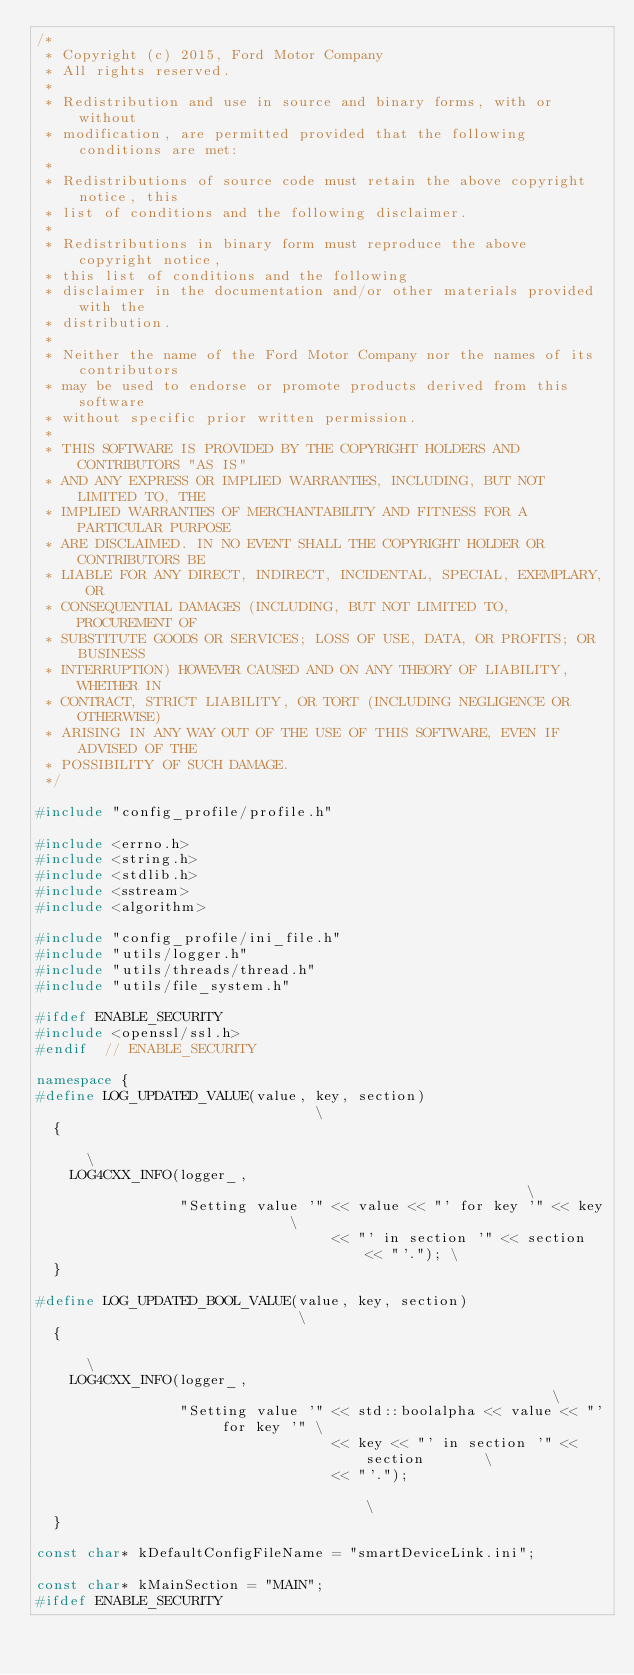<code> <loc_0><loc_0><loc_500><loc_500><_C++_>/*
 * Copyright (c) 2015, Ford Motor Company
 * All rights reserved.
 *
 * Redistribution and use in source and binary forms, with or without
 * modification, are permitted provided that the following conditions are met:
 *
 * Redistributions of source code must retain the above copyright notice, this
 * list of conditions and the following disclaimer.
 *
 * Redistributions in binary form must reproduce the above copyright notice,
 * this list of conditions and the following
 * disclaimer in the documentation and/or other materials provided with the
 * distribution.
 *
 * Neither the name of the Ford Motor Company nor the names of its contributors
 * may be used to endorse or promote products derived from this software
 * without specific prior written permission.
 *
 * THIS SOFTWARE IS PROVIDED BY THE COPYRIGHT HOLDERS AND CONTRIBUTORS "AS IS"
 * AND ANY EXPRESS OR IMPLIED WARRANTIES, INCLUDING, BUT NOT LIMITED TO, THE
 * IMPLIED WARRANTIES OF MERCHANTABILITY AND FITNESS FOR A PARTICULAR PURPOSE
 * ARE DISCLAIMED. IN NO EVENT SHALL THE COPYRIGHT HOLDER OR CONTRIBUTORS BE
 * LIABLE FOR ANY DIRECT, INDIRECT, INCIDENTAL, SPECIAL, EXEMPLARY, OR
 * CONSEQUENTIAL DAMAGES (INCLUDING, BUT NOT LIMITED TO, PROCUREMENT OF
 * SUBSTITUTE GOODS OR SERVICES; LOSS OF USE, DATA, OR PROFITS; OR BUSINESS
 * INTERRUPTION) HOWEVER CAUSED AND ON ANY THEORY OF LIABILITY, WHETHER IN
 * CONTRACT, STRICT LIABILITY, OR TORT (INCLUDING NEGLIGENCE OR OTHERWISE)
 * ARISING IN ANY WAY OUT OF THE USE OF THIS SOFTWARE, EVEN IF ADVISED OF THE
 * POSSIBILITY OF SUCH DAMAGE.
 */

#include "config_profile/profile.h"

#include <errno.h>
#include <string.h>
#include <stdlib.h>
#include <sstream>
#include <algorithm>

#include "config_profile/ini_file.h"
#include "utils/logger.h"
#include "utils/threads/thread.h"
#include "utils/file_system.h"

#ifdef ENABLE_SECURITY
#include <openssl/ssl.h>
#endif  // ENABLE_SECURITY

namespace {
#define LOG_UPDATED_VALUE(value, key, section)                              \
  {                                                                         \
    LOG4CXX_INFO(logger_,                                                   \
                 "Setting value '" << value << "' for key '" << key         \
                                   << "' in section '" << section << "'."); \
  }

#define LOG_UPDATED_BOOL_VALUE(value, key, section)                            \
  {                                                                            \
    LOG4CXX_INFO(logger_,                                                      \
                 "Setting value '" << std::boolalpha << value << "' for key '" \
                                   << key << "' in section '" << section       \
                                   << "'.");                                   \
  }

const char* kDefaultConfigFileName = "smartDeviceLink.ini";

const char* kMainSection = "MAIN";
#ifdef ENABLE_SECURITY</code> 